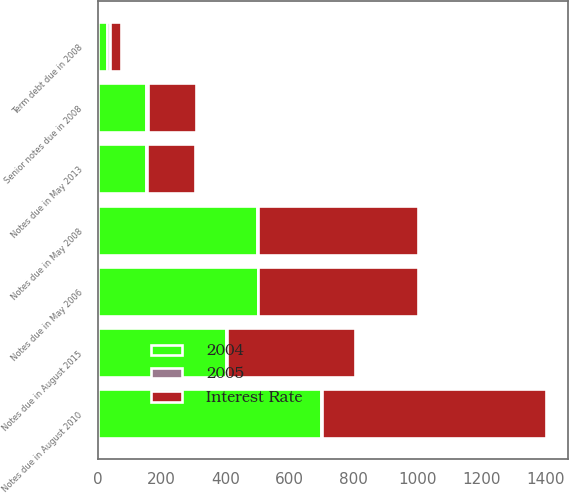Convert chart. <chart><loc_0><loc_0><loc_500><loc_500><stacked_bar_chart><ecel><fcel>Notes due in May 2006<fcel>Notes due in May 2008<fcel>Notes due in August 2010<fcel>Notes due in May 2013<fcel>Notes due in August 2015<fcel>Senior notes due in 2008<fcel>Term debt due in 2008<nl><fcel>2005<fcel>2.12<fcel>3<fcel>4.5<fcel>4.25<fcel>5.38<fcel>6.32<fcel>7.5<nl><fcel>2004<fcel>500<fcel>499<fcel>698<fcel>150<fcel>400<fcel>150<fcel>30<nl><fcel>Interest Rate<fcel>499<fcel>499<fcel>698<fcel>150<fcel>400<fcel>150<fcel>35<nl></chart> 